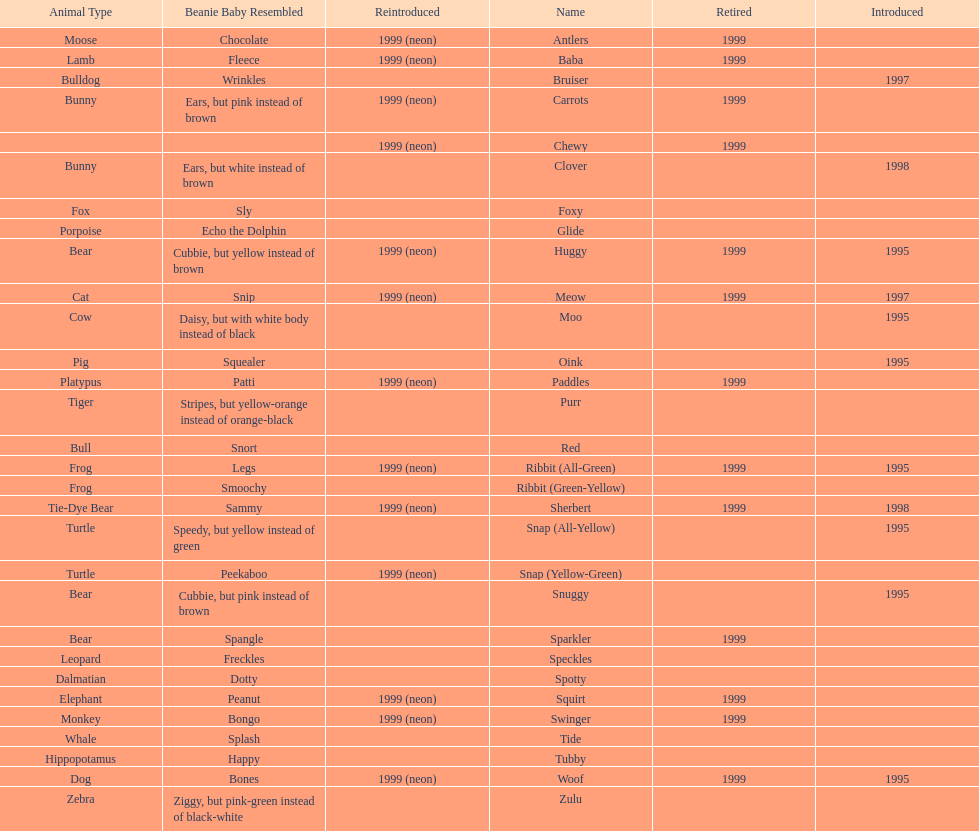What is the sum of pillow pals that were both revived and ceased in 1999? 12. 